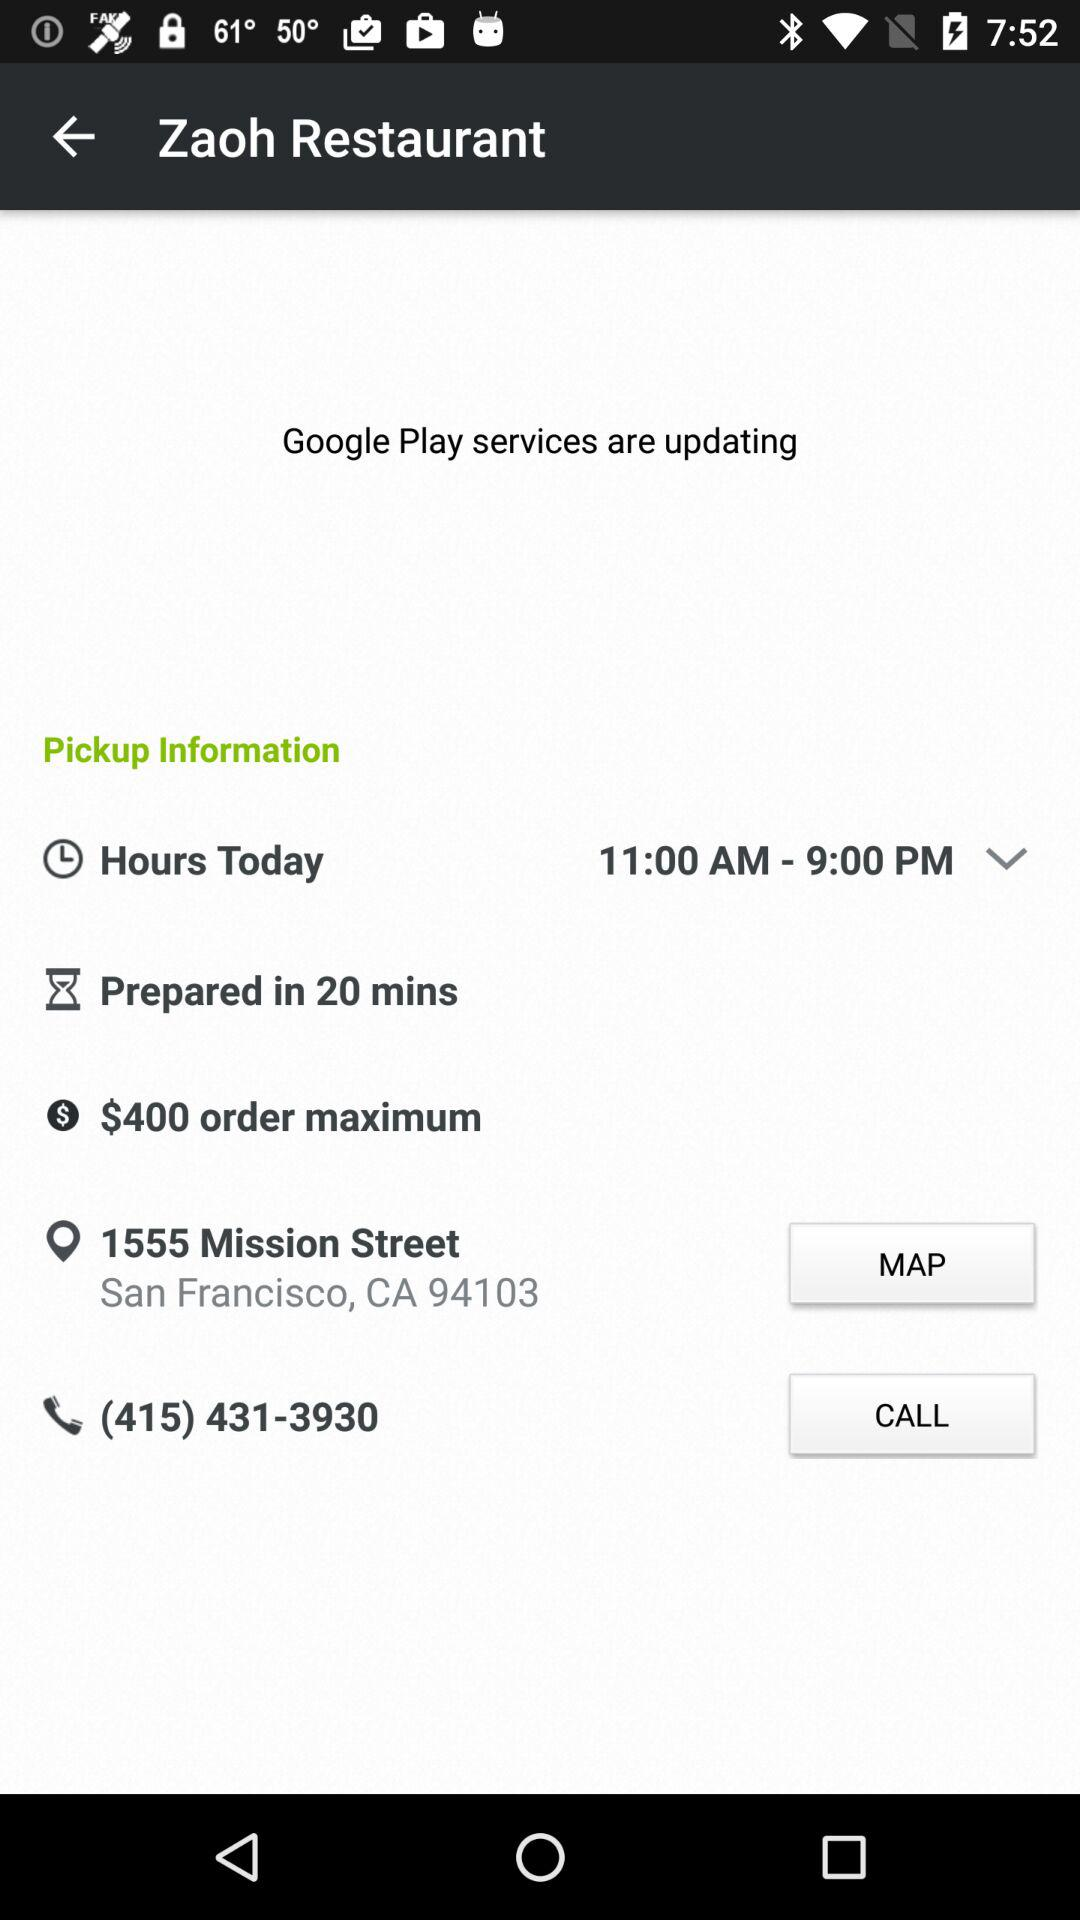What is the maximum order amount? The maximum order amount is $400. 